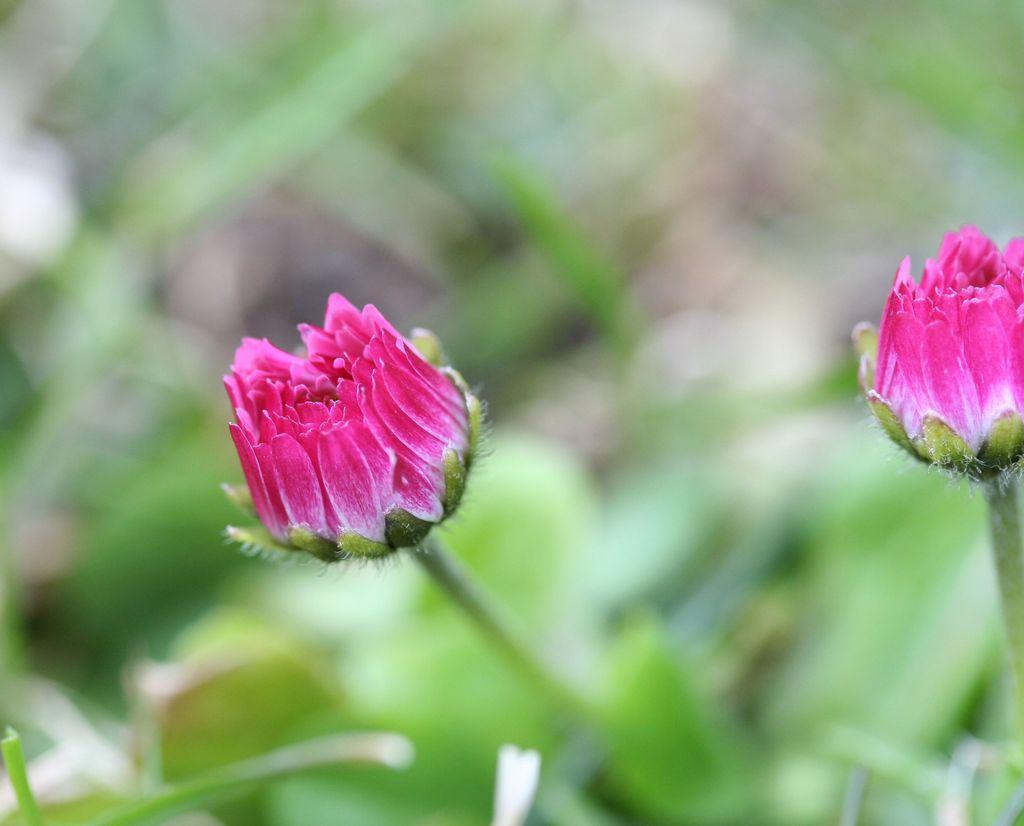In one or two sentences, can you explain what this image depicts? In this picture there are two flowers which are in pink color and there is greenery below it. 